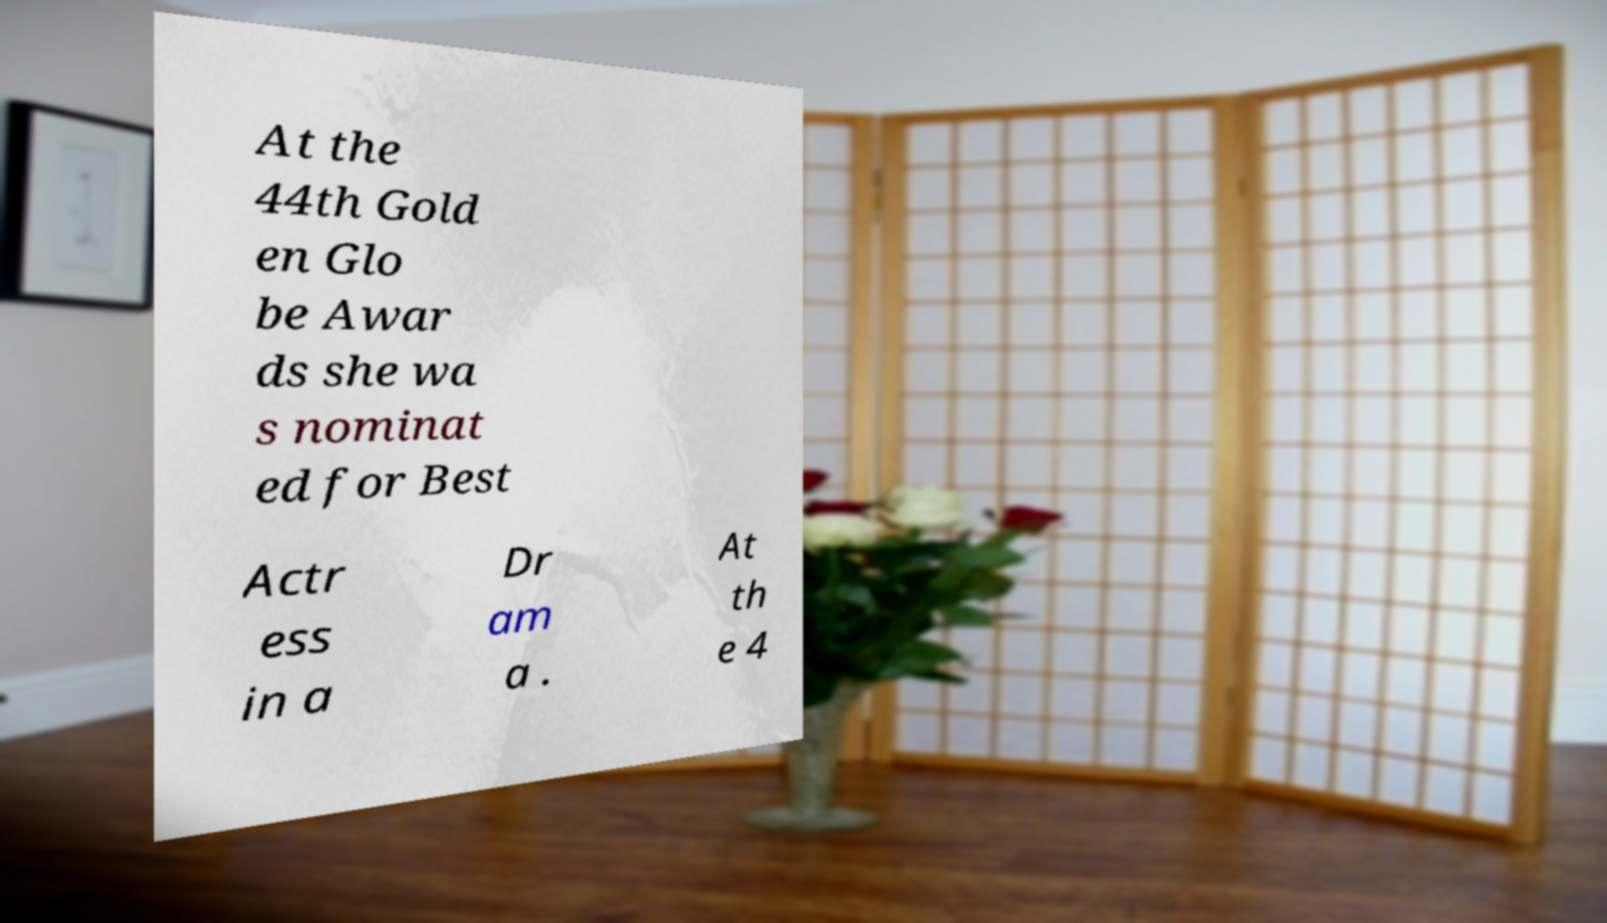Can you read and provide the text displayed in the image?This photo seems to have some interesting text. Can you extract and type it out for me? At the 44th Gold en Glo be Awar ds she wa s nominat ed for Best Actr ess in a Dr am a . At th e 4 